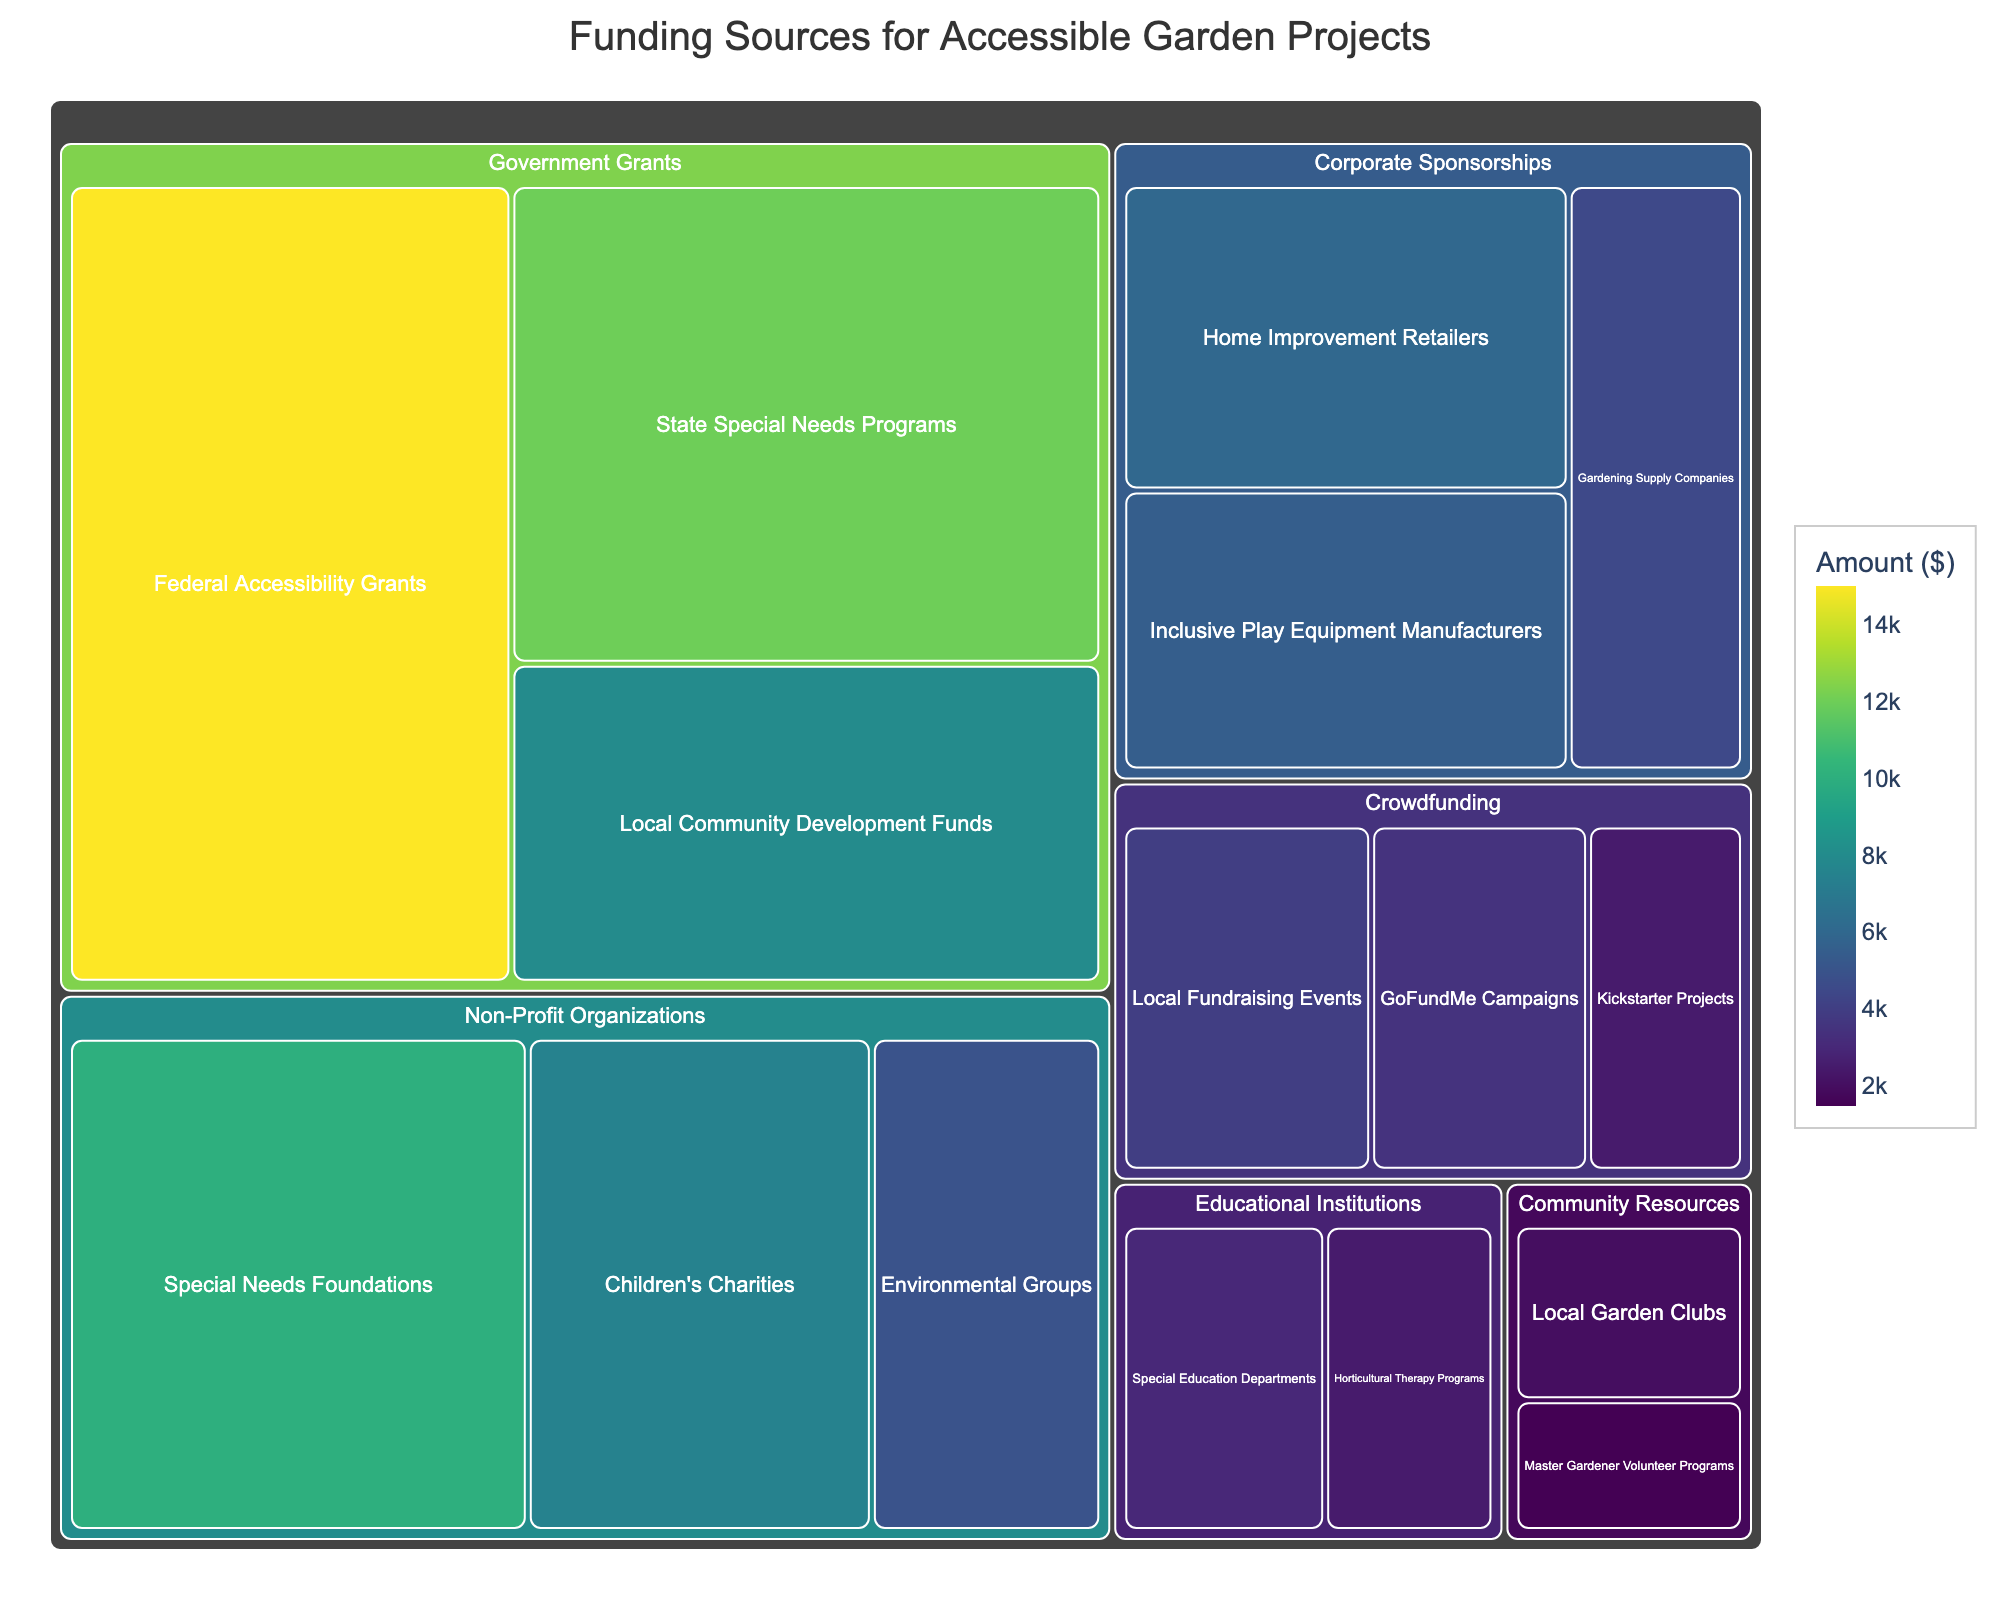what is the title of the figure? The title is provided at the top of the figure and usually describes what the visualization is showing. This helps users understand the context of the data.
Answer: Funding Sources for Accessible Garden Projects Which category has the highest total amount of funding? To find out the highest total amount of funding, look at all subcategories within each main category and sum them up. Compare these sums across all categories.
Answer: Government Grants How much funding is provided by Children's Charities? Locate the subcategory "Children's Charities" under the "Non-Profit Organizations" category and check the amount displayed.
Answer: 7,500 Among Non-Profit Organizations, which subcategory has the least funding? Compare the amounts of all the subcategories within the "Non-Profit Organizations" category to find the one with the smallest value.
Answer: Environmental Groups What is the combined total amount of funding from State Special Needs Programs and Local Community Development Funds? Add the amounts from the "State Special Needs Programs" and "Local Community Development Funds" subcategories. 12,000 + 8,000 = 20,000
Answer: 20,000 Which category has the most number of subcategories? Count the subcategories within each main category and determine which one has the highest count.
Answer: Non-Profit Organizations What is the difference in funding between Home Improvement Retailers and Gardening Supply Companies? Subtract the funding amount of Gardening Supply Companies from the funding amount of Home Improvement Retailers. 6,000 - 4,500 = 1,500
Answer: 1,500 In Crowdfunding, which subcategory contributes the least to the total amount? Compare the funding amounts within the "Crowdfunding" category to identify the one with the smallest contribution.
Answer: Kickstarter Projects What is the total amount of funding provided by Community Resources? Sum the amounts of all subcategories within the "Community Resources" category. 1,500 + 2,000 = 3,500
Answer: 3,500 How does the funding for GoFundMe Campaigns compare to the funding for Local Fundraising Events? Compare the amounts between the "GoFundMe Campaigns" and "Local Fundraising Events" subcategories and state which one is greater.
Answer: Local Fundraising Events have more funding than GoFundMe Campaigns Which subcategory under Corporate Sponsorships has the highest funding? Identify the subcategory in the "Corporate Sponsorships" category with the highest funding amount.
Answer: Home Improvement Retailers 